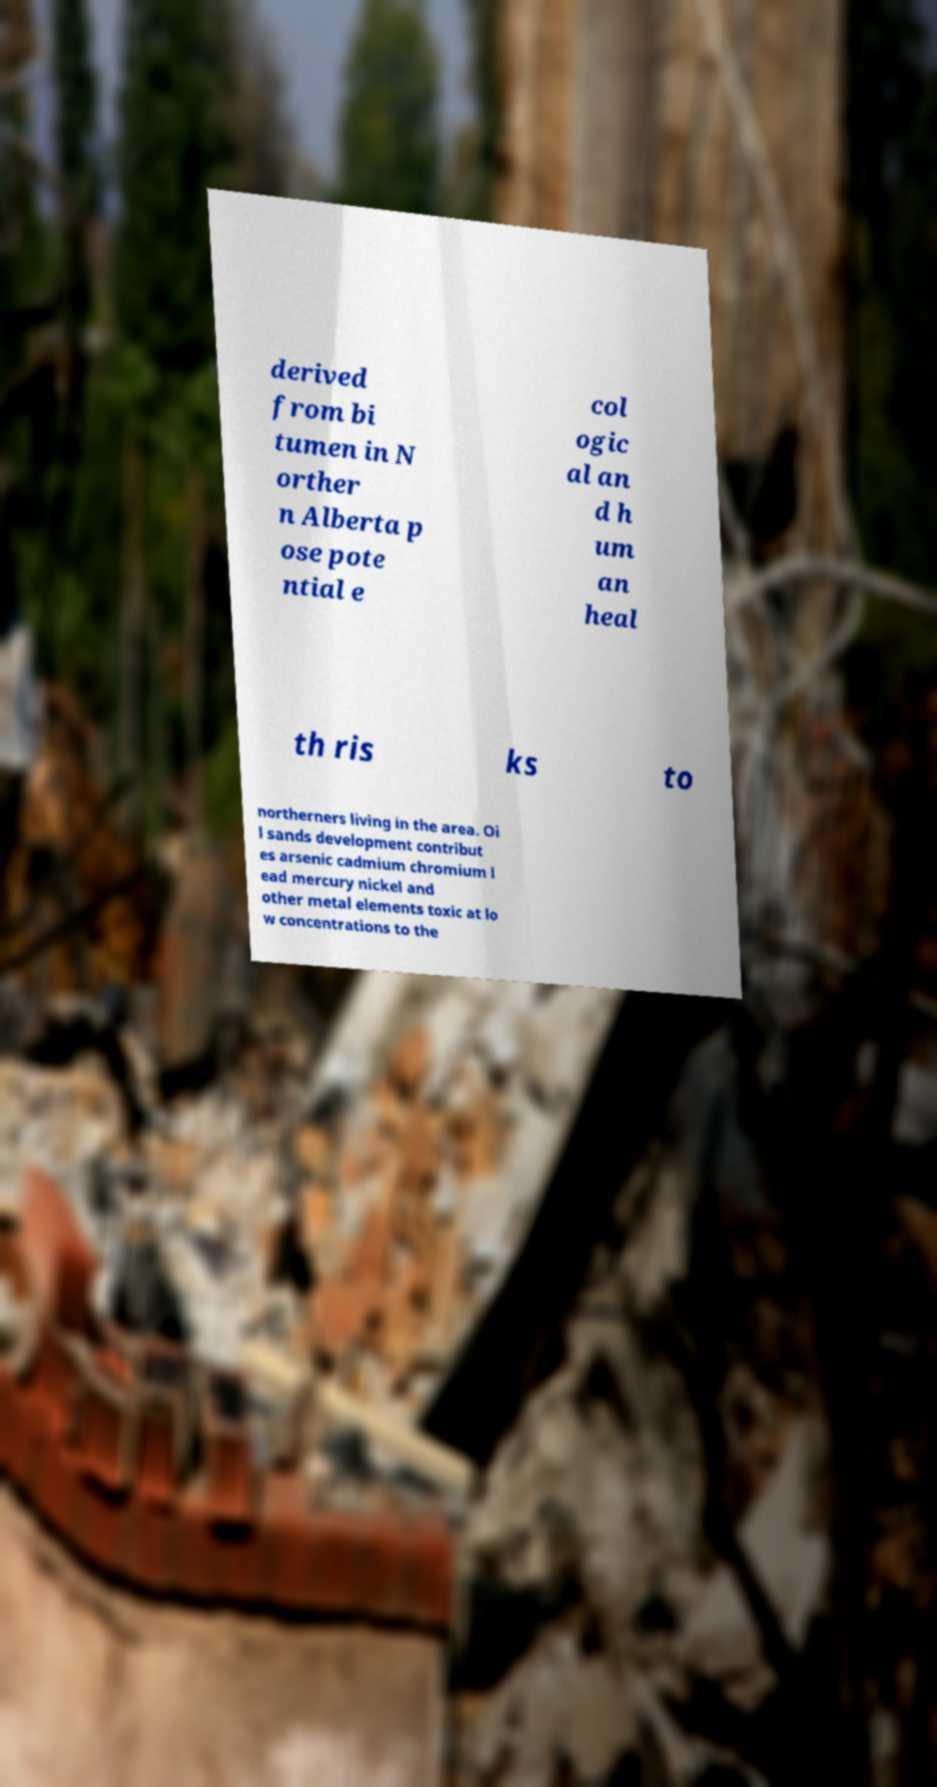There's text embedded in this image that I need extracted. Can you transcribe it verbatim? derived from bi tumen in N orther n Alberta p ose pote ntial e col ogic al an d h um an heal th ris ks to northerners living in the area. Oi l sands development contribut es arsenic cadmium chromium l ead mercury nickel and other metal elements toxic at lo w concentrations to the 